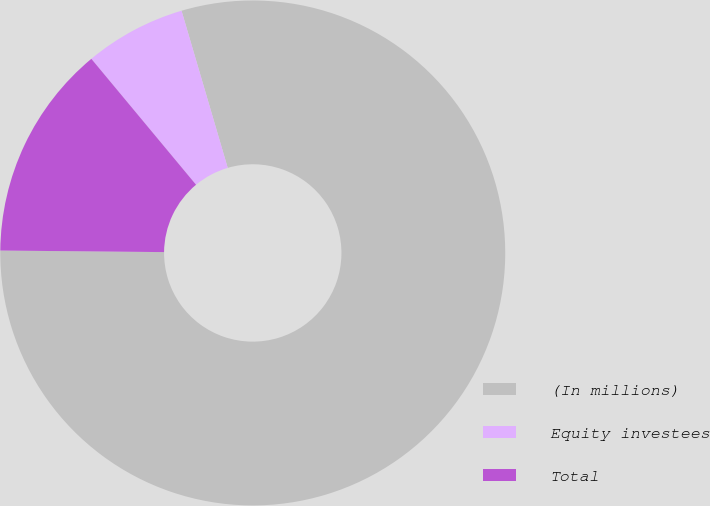<chart> <loc_0><loc_0><loc_500><loc_500><pie_chart><fcel>(In millions)<fcel>Equity investees<fcel>Total<nl><fcel>79.71%<fcel>6.49%<fcel>13.81%<nl></chart> 